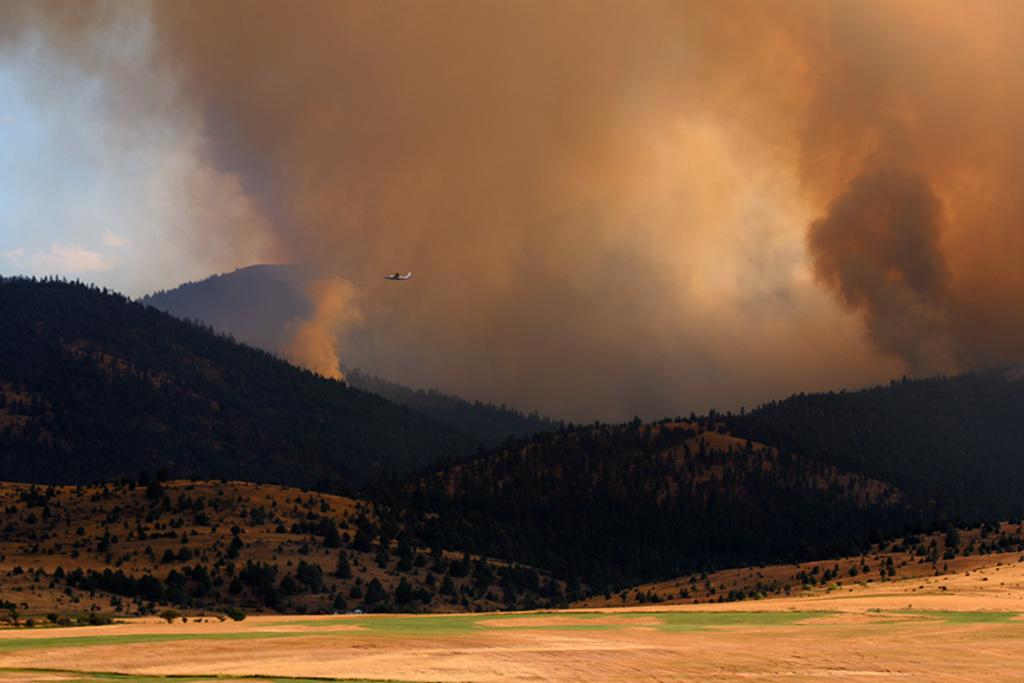What type of natural elements can be seen in the image? There are trees and hills visible in the image. What is flying in the air in the image? There is an airplane flying in the air in the image. What might be causing the smoke visible in the image? The source of the smoke is not clear from the image, but it could be from the airplane or another source. What is visible in the background of the image? There is a sky visible in the background of the image. How many ants are crawling on the border of the image? There are no ants present in the image, and therefore no such activity can be observed. 